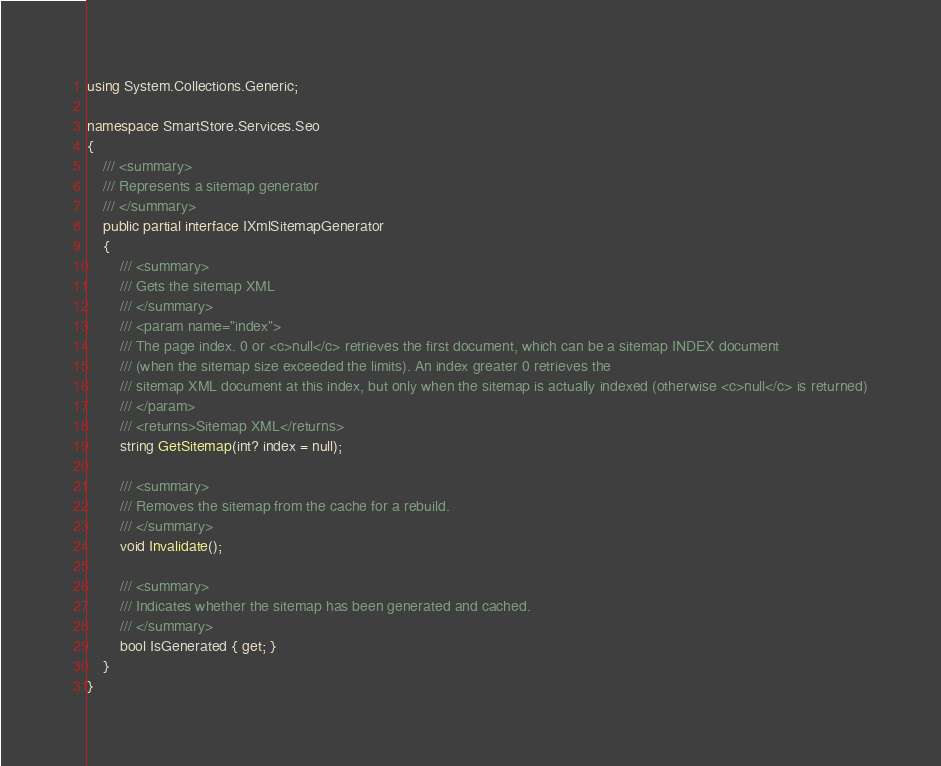Convert code to text. <code><loc_0><loc_0><loc_500><loc_500><_C#_>using System.Collections.Generic;

namespace SmartStore.Services.Seo
{
    /// <summary>
    /// Represents a sitemap generator
    /// </summary>
    public partial interface IXmlSitemapGenerator
    {
		/// <summary>
		/// Gets the sitemap XML
		/// </summary>
		/// <param name="index">
		/// The page index. 0 or <c>null</c> retrieves the first document, which can be a sitemap INDEX document
		/// (when the sitemap size exceeded the limits). An index greater 0 retrieves the
		/// sitemap XML document at this index, but only when the sitemap is actually indexed (otherwise <c>null</c> is returned)
		/// </param>
		/// <returns>Sitemap XML</returns>
		string GetSitemap(int? index = null);

		/// <summary>
		/// Removes the sitemap from the cache for a rebuild.
		/// </summary>
		void Invalidate();

		/// <summary>
		/// Indicates whether the sitemap has been generated and cached.
		/// </summary>
		bool IsGenerated { get; }
	}
}
</code> 